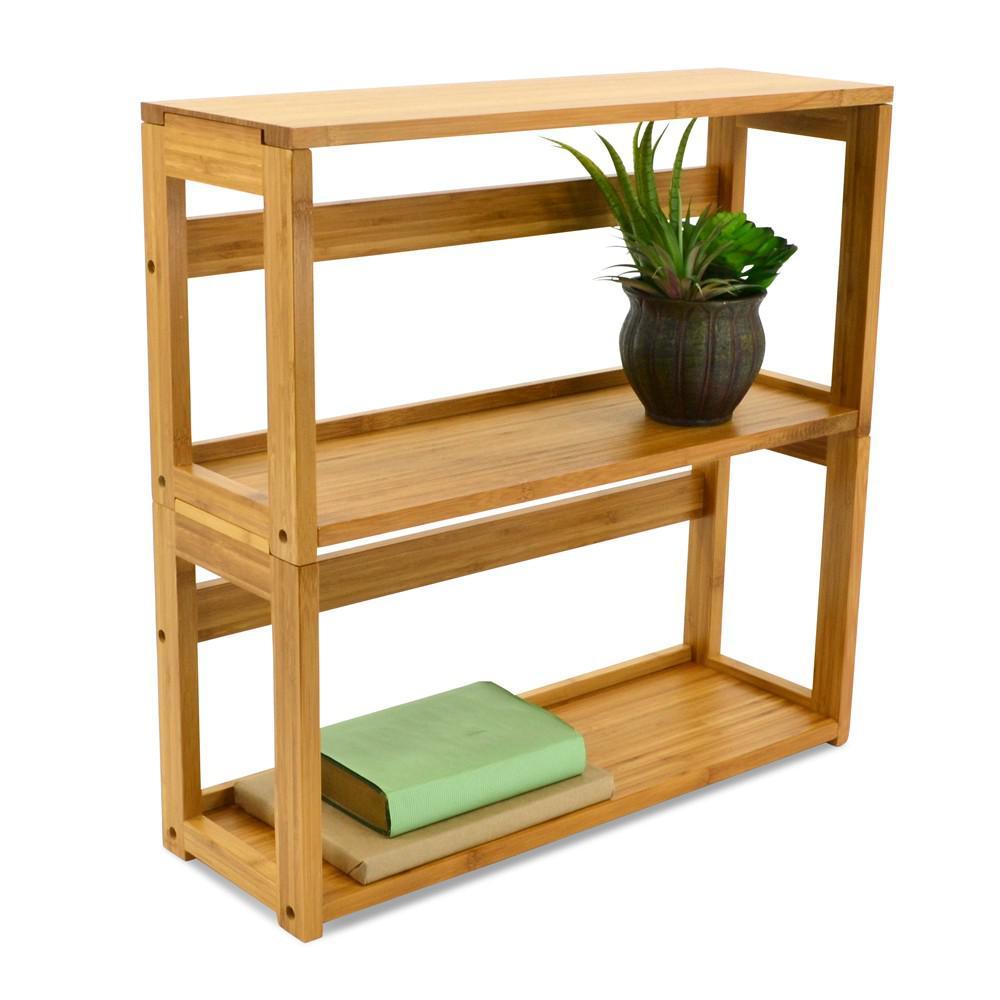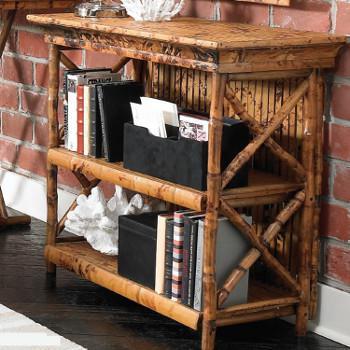The first image is the image on the left, the second image is the image on the right. Evaluate the accuracy of this statement regarding the images: "Two shelves are the same overall shape and have the same number of shelves, but one is made of bamboo while the other is finished wood.". Is it true? Answer yes or no. Yes. The first image is the image on the left, the second image is the image on the right. Evaluate the accuracy of this statement regarding the images: "Left image shows a blond 'traditional' wood shelf unit, and right image shows a rattan shelf unit.". Is it true? Answer yes or no. Yes. 